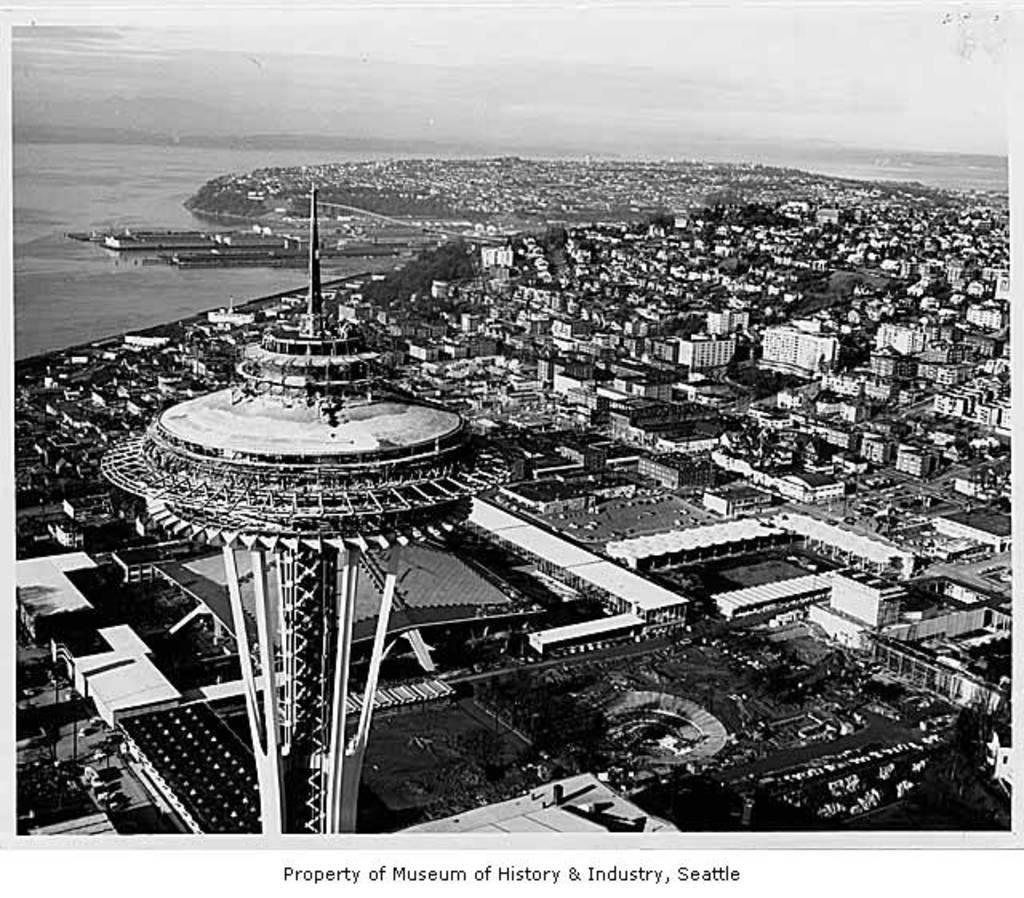How would you summarize this image in a sentence or two? This is a black and white image. In this image there are buildings. There is water. At the top of the image there is sky. In the foreground of the image there is a tower. At the bottom of the image there is text. 